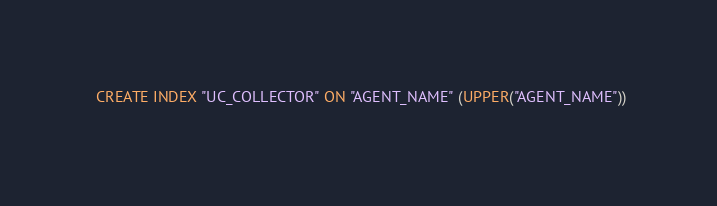<code> <loc_0><loc_0><loc_500><loc_500><_SQL_>
  CREATE INDEX "UC_COLLECTOR" ON "AGENT_NAME" (UPPER("AGENT_NAME")) 
  </code> 